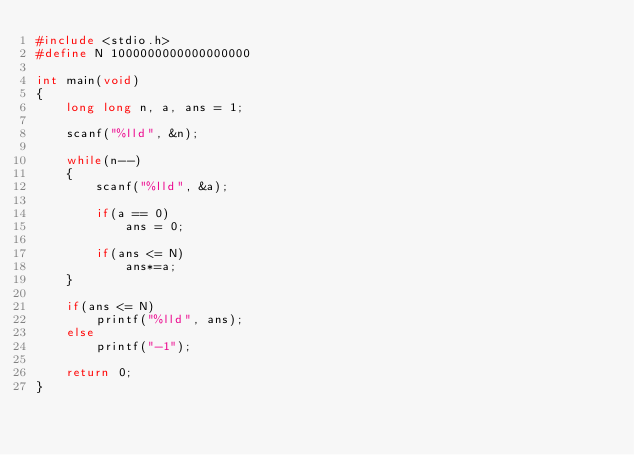<code> <loc_0><loc_0><loc_500><loc_500><_C_>#include <stdio.h>
#define N 1000000000000000000

int main(void)
{
    long long n, a, ans = 1;

    scanf("%lld", &n);

    while(n--)
    {
        scanf("%lld", &a);

        if(a == 0)
            ans = 0;

        if(ans <= N)
            ans*=a;
    }

    if(ans <= N)
        printf("%lld", ans);
    else
        printf("-1");

    return 0;
}
</code> 